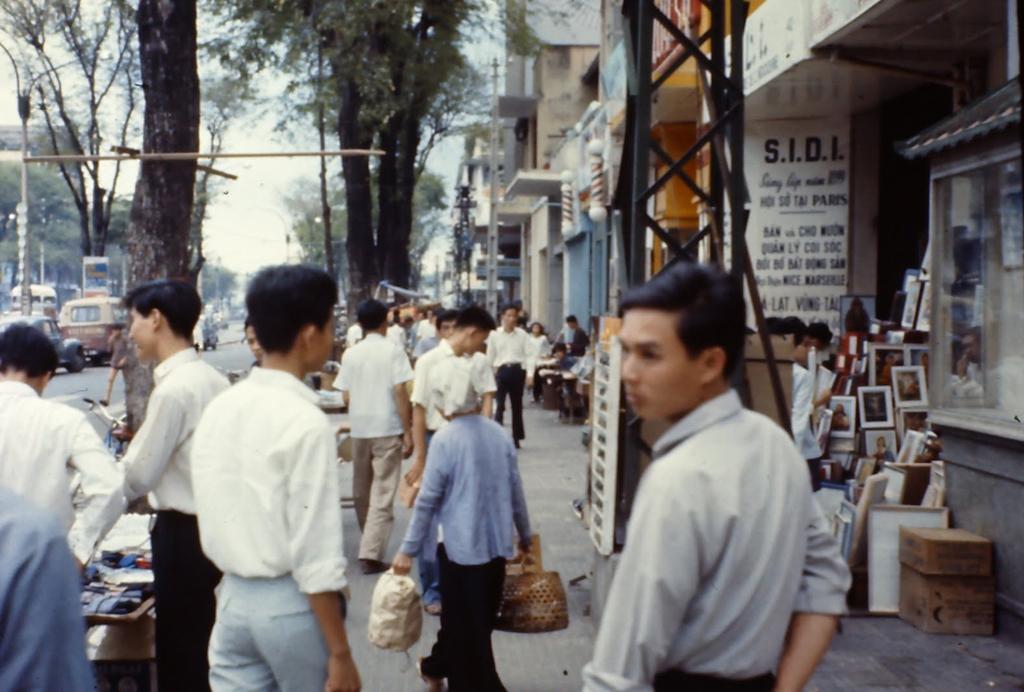Can you describe this image briefly? In the image on the footpath there are people. In the background there are buildings with walls, windows and posters. On the right side of the image there is a glass. Beside that there are many frames and cardboard boxes on the floor. In the background there are trees, poles and vehicles on the road. 